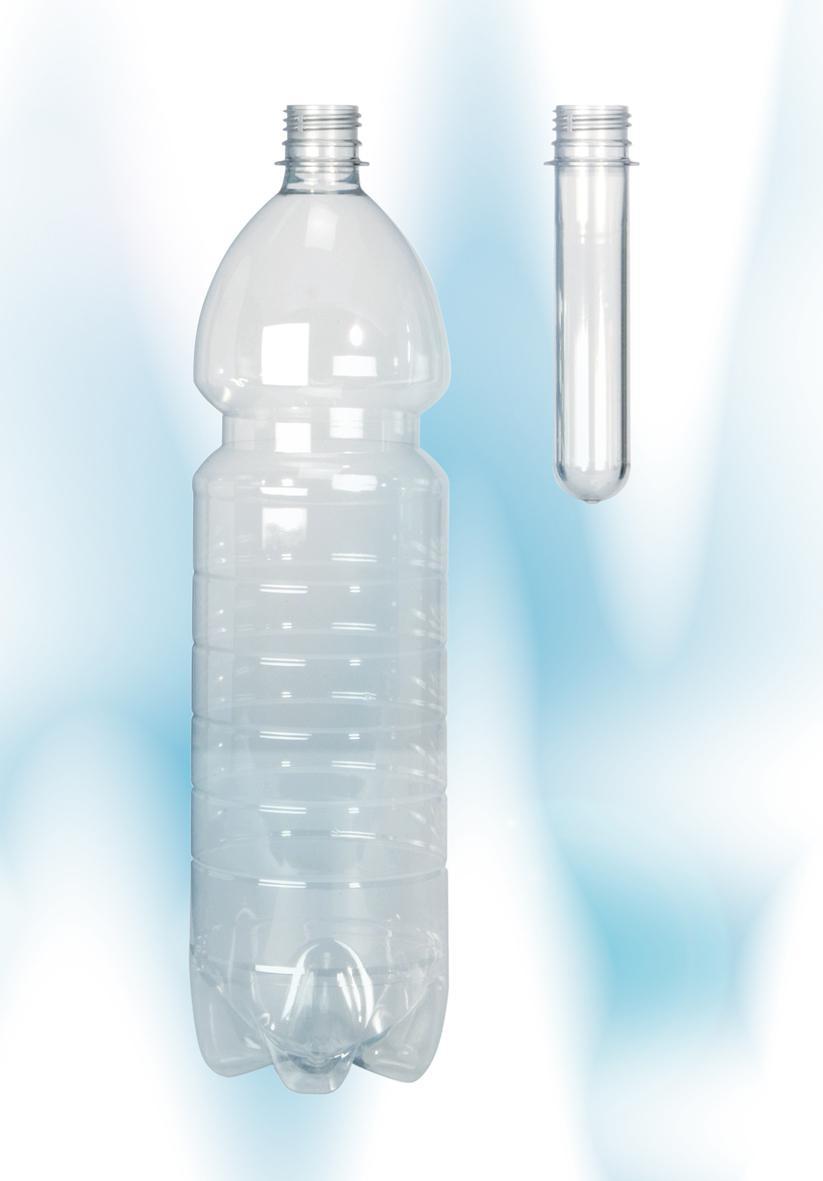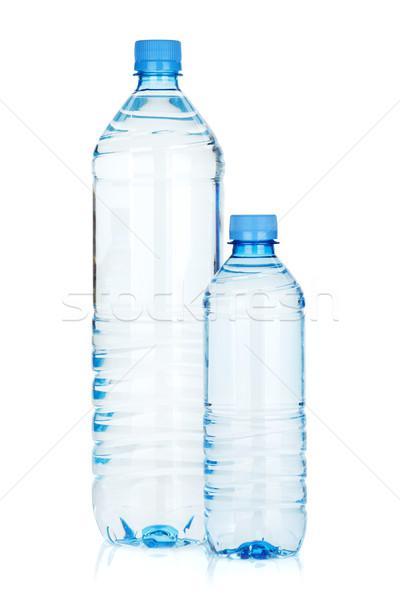The first image is the image on the left, the second image is the image on the right. Analyze the images presented: Is the assertion "An image shows an upright water bottle next to one lying on its side." valid? Answer yes or no. No. The first image is the image on the left, the second image is the image on the right. Examine the images to the left and right. Is the description "There is a bottle laying sideways in one of the images." accurate? Answer yes or no. No. 